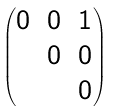Convert formula to latex. <formula><loc_0><loc_0><loc_500><loc_500>\begin{pmatrix} 0 & 0 & 1 \\ & 0 & 0 \\ & & 0 \end{pmatrix}</formula> 